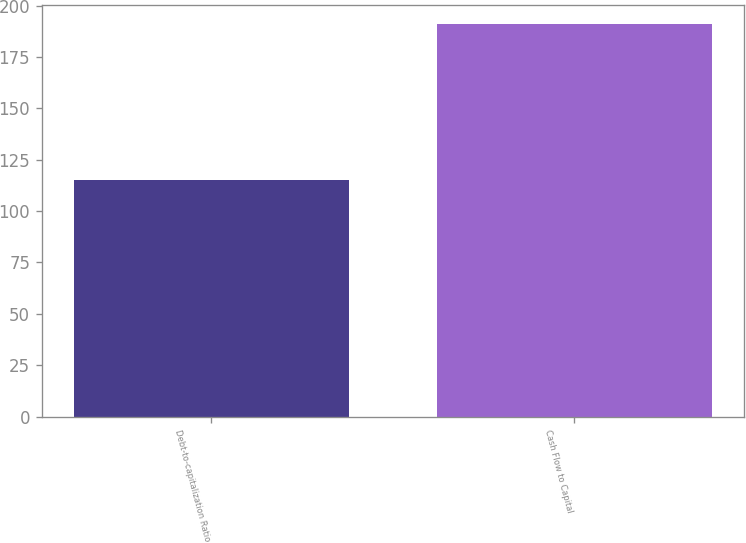Convert chart to OTSL. <chart><loc_0><loc_0><loc_500><loc_500><bar_chart><fcel>Debt-to-capitalization Ratio<fcel>Cash Flow to Capital<nl><fcel>115<fcel>191<nl></chart> 